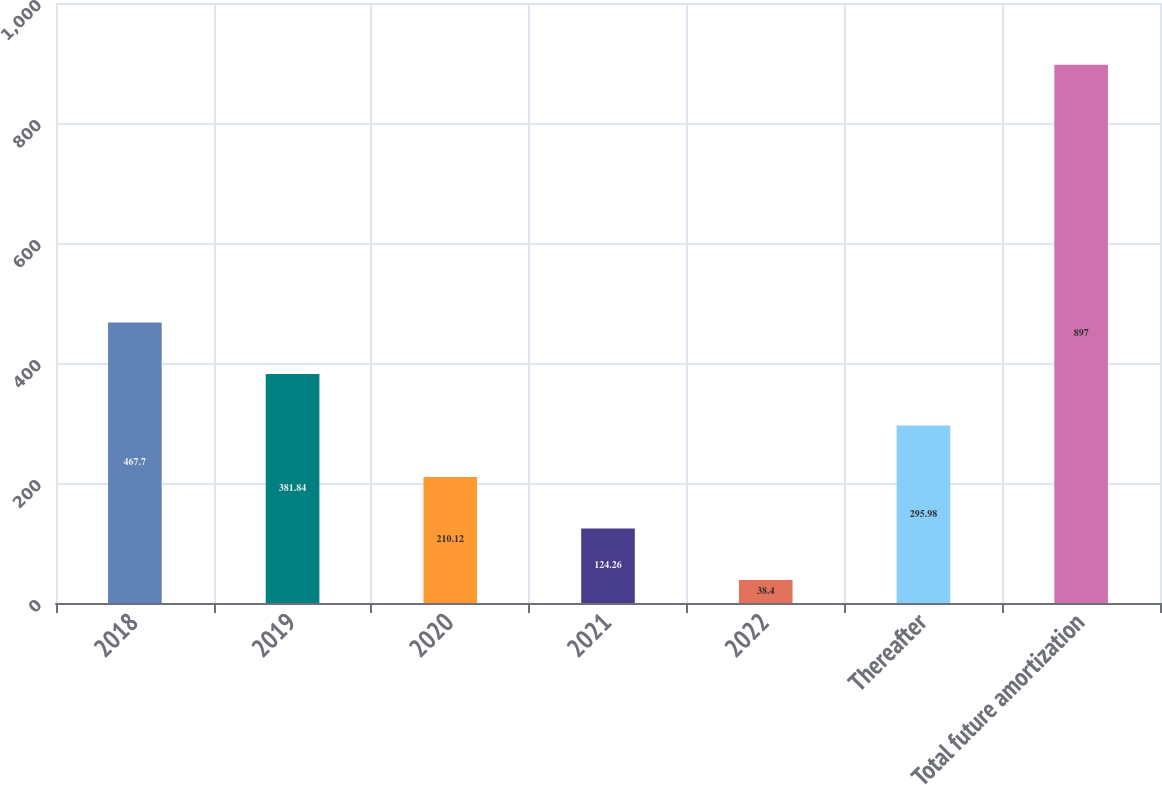Convert chart. <chart><loc_0><loc_0><loc_500><loc_500><bar_chart><fcel>2018<fcel>2019<fcel>2020<fcel>2021<fcel>2022<fcel>Thereafter<fcel>Total future amortization<nl><fcel>467.7<fcel>381.84<fcel>210.12<fcel>124.26<fcel>38.4<fcel>295.98<fcel>897<nl></chart> 